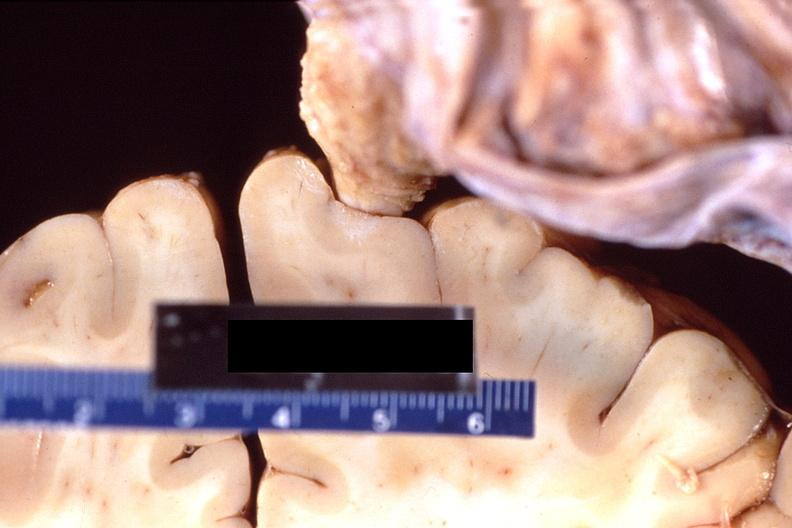does this image show brain, breast cancer metastasis to meninges?
Answer the question using a single word or phrase. Yes 